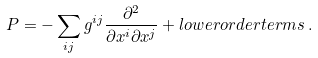<formula> <loc_0><loc_0><loc_500><loc_500>P = - \sum _ { i j } g ^ { i j } \frac { \partial ^ { 2 } } { \partial x ^ { i } \partial x ^ { j } } + l o w e r o r d e r t e r m s \, .</formula> 